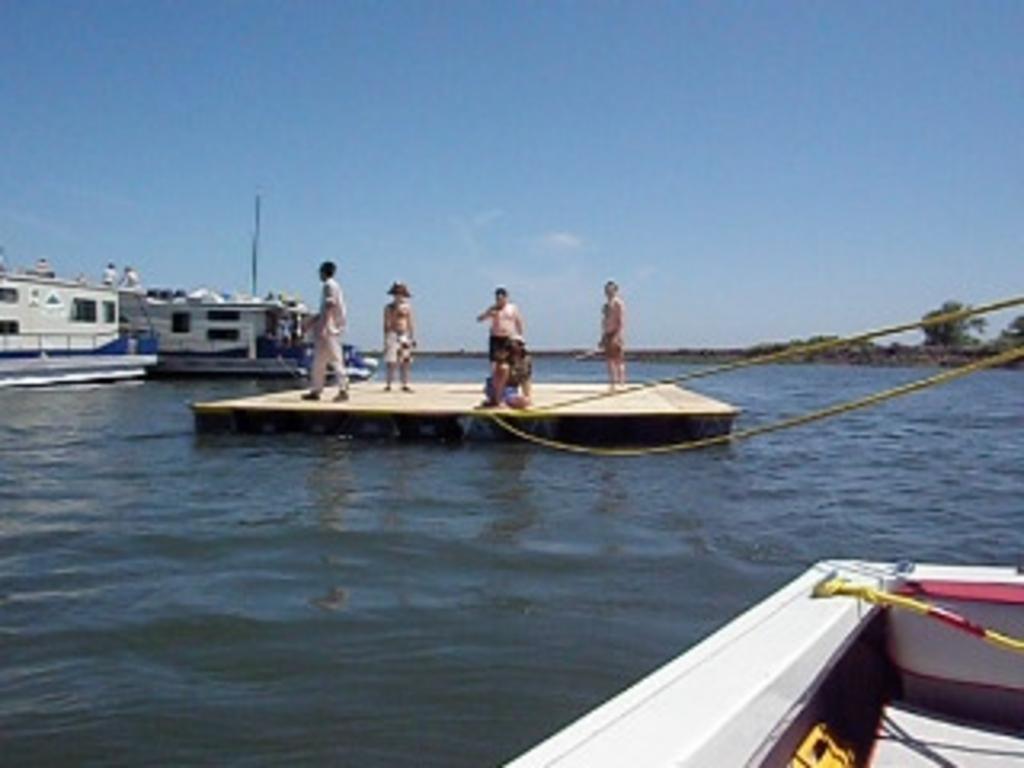Could you give a brief overview of what you see in this image? In front of the image there are a few people on the wooden platform on the water connected with ropes to a boat. Behind them there are people on the boats. In the background of the image there are trees. At the top of the image there are clouds in the sky.  